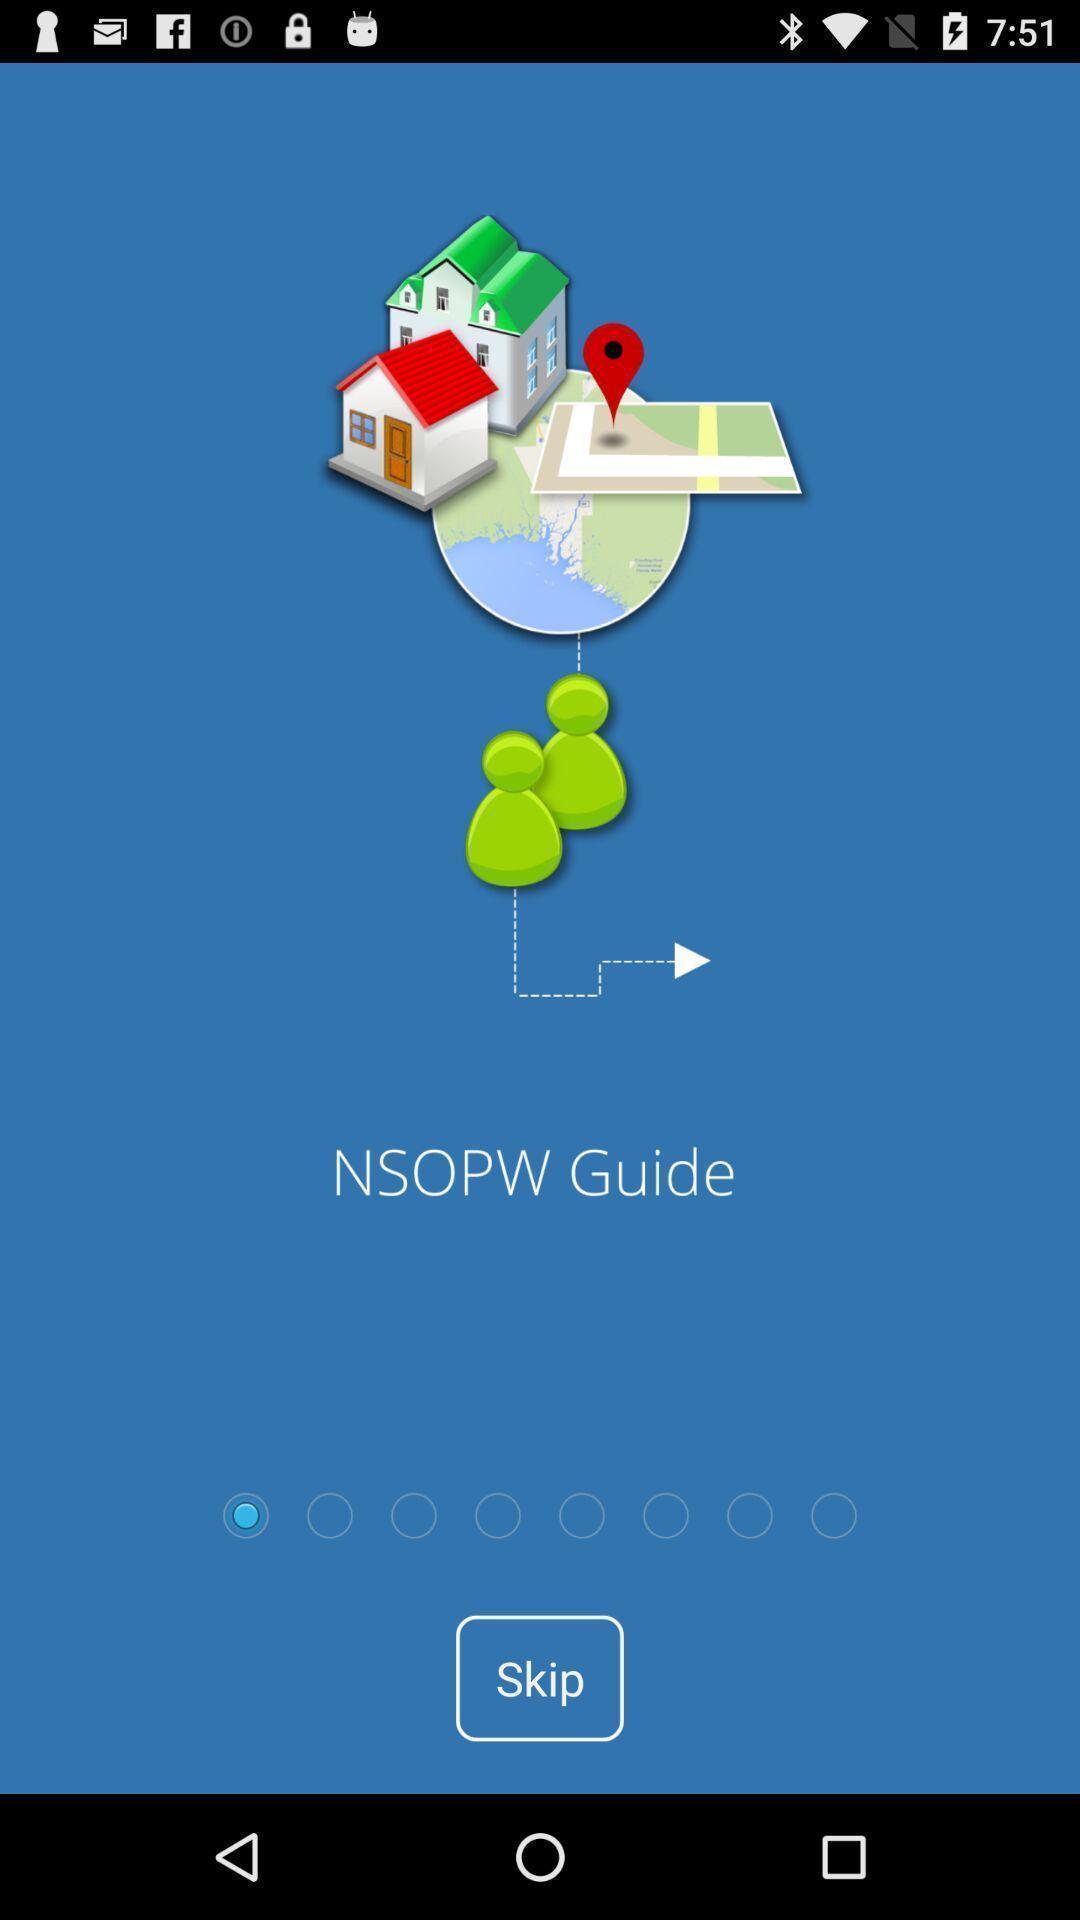What details can you identify in this image? Welcome page of a naviagtion app. 